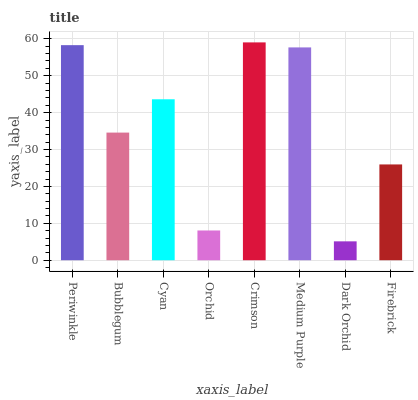Is Dark Orchid the minimum?
Answer yes or no. Yes. Is Crimson the maximum?
Answer yes or no. Yes. Is Bubblegum the minimum?
Answer yes or no. No. Is Bubblegum the maximum?
Answer yes or no. No. Is Periwinkle greater than Bubblegum?
Answer yes or no. Yes. Is Bubblegum less than Periwinkle?
Answer yes or no. Yes. Is Bubblegum greater than Periwinkle?
Answer yes or no. No. Is Periwinkle less than Bubblegum?
Answer yes or no. No. Is Cyan the high median?
Answer yes or no. Yes. Is Bubblegum the low median?
Answer yes or no. Yes. Is Periwinkle the high median?
Answer yes or no. No. Is Dark Orchid the low median?
Answer yes or no. No. 